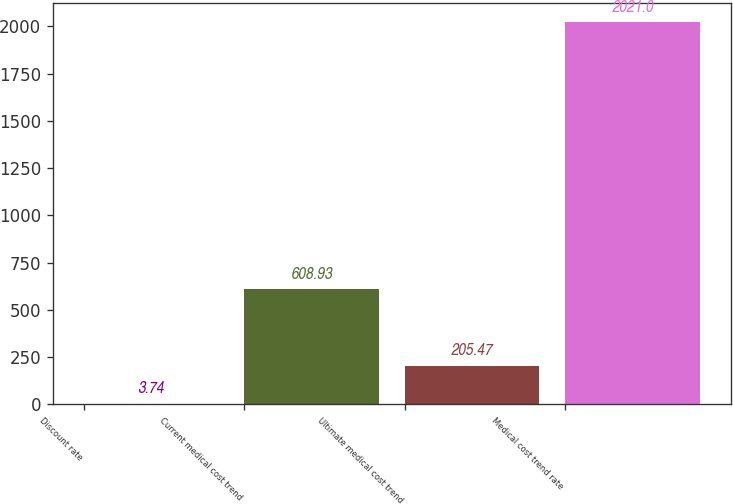<chart> <loc_0><loc_0><loc_500><loc_500><bar_chart><fcel>Discount rate<fcel>Current medical cost trend<fcel>Ultimate medical cost trend<fcel>Medical cost trend rate<nl><fcel>3.74<fcel>608.93<fcel>205.47<fcel>2021<nl></chart> 